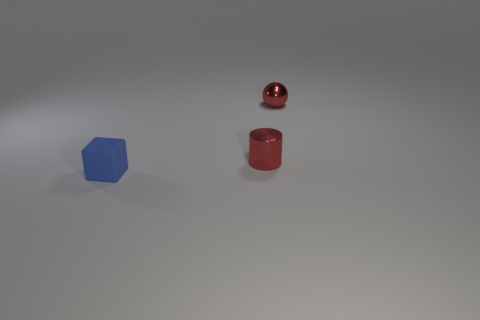How many tiny objects have the same color as the small ball?
Your response must be concise. 1. How many things are made of the same material as the tiny red sphere?
Make the answer very short. 1. What is the size of the thing that is behind the small red thing in front of the tiny metallic object behind the shiny cylinder?
Offer a very short reply. Small. What number of small metal cylinders are behind the tiny rubber block?
Give a very brief answer. 1. Is the number of big matte cylinders greater than the number of tiny blue blocks?
Give a very brief answer. No. The ball that is the same color as the tiny shiny cylinder is what size?
Your response must be concise. Small. What is the size of the thing that is both on the left side of the sphere and to the right of the matte thing?
Offer a very short reply. Small. What material is the red object in front of the small shiny thing behind the red thing that is in front of the tiny ball made of?
Make the answer very short. Metal. There is a tiny thing that is the same color as the small cylinder; what is it made of?
Your answer should be compact. Metal. Is the color of the small metallic thing that is in front of the shiny sphere the same as the tiny metallic sphere that is behind the small cylinder?
Provide a short and direct response. Yes. 